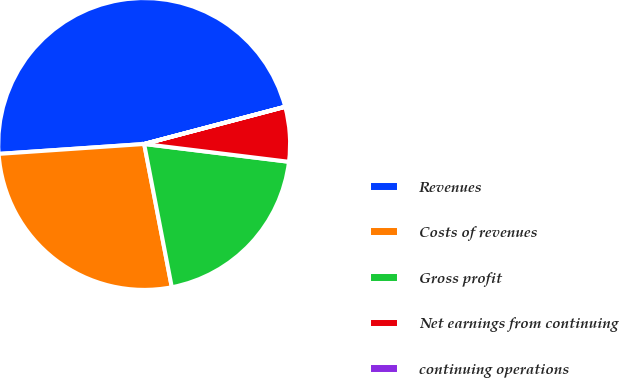Convert chart. <chart><loc_0><loc_0><loc_500><loc_500><pie_chart><fcel>Revenues<fcel>Costs of revenues<fcel>Gross profit<fcel>Net earnings from continuing<fcel>continuing operations<nl><fcel>46.97%<fcel>26.95%<fcel>20.02%<fcel>6.05%<fcel>0.01%<nl></chart> 